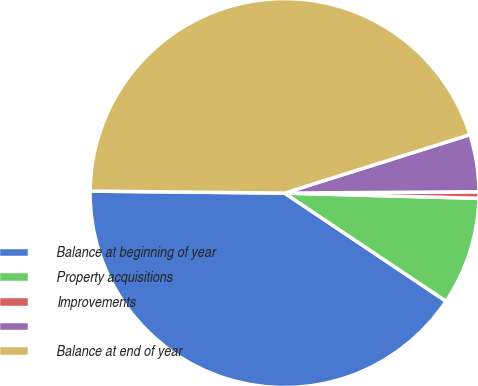Convert chart. <chart><loc_0><loc_0><loc_500><loc_500><pie_chart><fcel>Balance at beginning of year<fcel>Property acquisitions<fcel>Improvements<fcel>Unnamed: 3<fcel>Balance at end of year<nl><fcel>40.77%<fcel>8.96%<fcel>0.54%<fcel>4.75%<fcel>44.98%<nl></chart> 